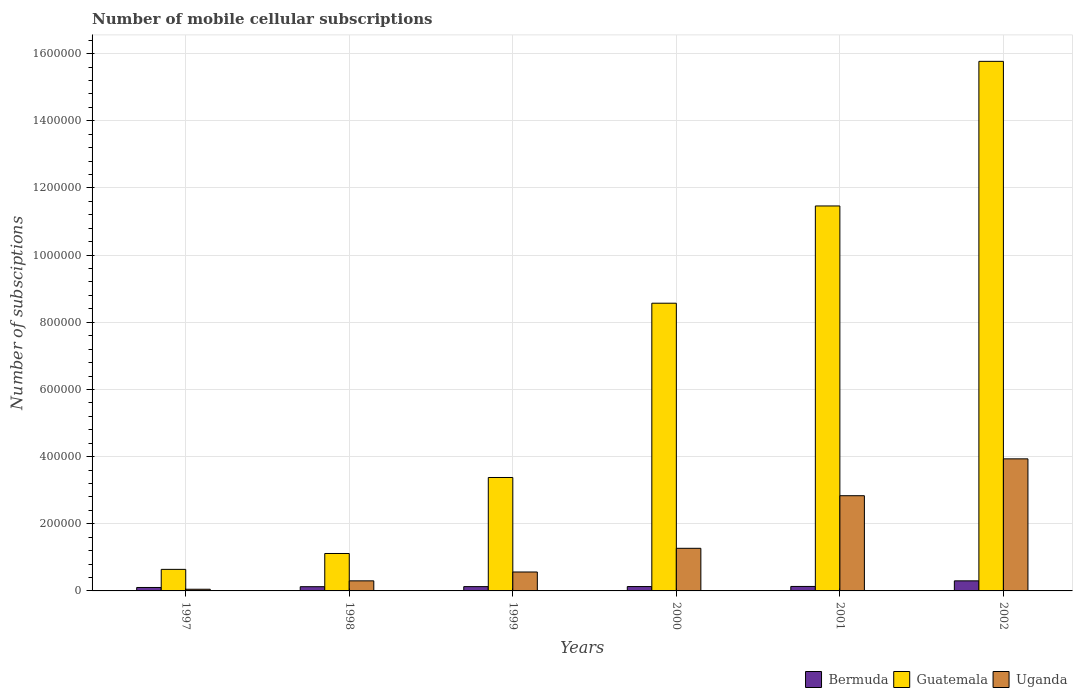How many groups of bars are there?
Make the answer very short. 6. How many bars are there on the 3rd tick from the left?
Your answer should be compact. 3. What is the label of the 6th group of bars from the left?
Give a very brief answer. 2002. What is the number of mobile cellular subscriptions in Guatemala in 2000?
Your response must be concise. 8.57e+05. Across all years, what is the minimum number of mobile cellular subscriptions in Guatemala?
Ensure brevity in your answer.  6.42e+04. In which year was the number of mobile cellular subscriptions in Guatemala maximum?
Offer a terse response. 2002. What is the total number of mobile cellular subscriptions in Guatemala in the graph?
Keep it short and to the point. 4.09e+06. What is the difference between the number of mobile cellular subscriptions in Guatemala in 1998 and that in 2000?
Make the answer very short. -7.45e+05. What is the difference between the number of mobile cellular subscriptions in Guatemala in 2002 and the number of mobile cellular subscriptions in Uganda in 1999?
Ensure brevity in your answer.  1.52e+06. What is the average number of mobile cellular subscriptions in Uganda per year?
Ensure brevity in your answer.  1.49e+05. In the year 1997, what is the difference between the number of mobile cellular subscriptions in Guatemala and number of mobile cellular subscriptions in Uganda?
Offer a terse response. 5.92e+04. What is the ratio of the number of mobile cellular subscriptions in Bermuda in 1999 to that in 2002?
Give a very brief answer. 0.43. What is the difference between the highest and the second highest number of mobile cellular subscriptions in Bermuda?
Keep it short and to the point. 1.67e+04. What is the difference between the highest and the lowest number of mobile cellular subscriptions in Guatemala?
Provide a short and direct response. 1.51e+06. In how many years, is the number of mobile cellular subscriptions in Bermuda greater than the average number of mobile cellular subscriptions in Bermuda taken over all years?
Make the answer very short. 1. Is the sum of the number of mobile cellular subscriptions in Uganda in 1998 and 1999 greater than the maximum number of mobile cellular subscriptions in Bermuda across all years?
Provide a short and direct response. Yes. What does the 1st bar from the left in 1999 represents?
Provide a succinct answer. Bermuda. What does the 2nd bar from the right in 2002 represents?
Keep it short and to the point. Guatemala. Is it the case that in every year, the sum of the number of mobile cellular subscriptions in Guatemala and number of mobile cellular subscriptions in Uganda is greater than the number of mobile cellular subscriptions in Bermuda?
Your response must be concise. Yes. What is the difference between two consecutive major ticks on the Y-axis?
Your response must be concise. 2.00e+05. Does the graph contain any zero values?
Offer a very short reply. No. Does the graph contain grids?
Provide a short and direct response. Yes. Where does the legend appear in the graph?
Your answer should be very brief. Bottom right. How many legend labels are there?
Offer a terse response. 3. How are the legend labels stacked?
Offer a terse response. Horizontal. What is the title of the graph?
Make the answer very short. Number of mobile cellular subscriptions. Does "Latin America(developing only)" appear as one of the legend labels in the graph?
Ensure brevity in your answer.  No. What is the label or title of the Y-axis?
Ensure brevity in your answer.  Number of subsciptions. What is the Number of subsciptions of Bermuda in 1997?
Offer a terse response. 1.03e+04. What is the Number of subsciptions of Guatemala in 1997?
Your response must be concise. 6.42e+04. What is the Number of subsciptions in Uganda in 1997?
Provide a short and direct response. 5000. What is the Number of subsciptions of Bermuda in 1998?
Give a very brief answer. 1.26e+04. What is the Number of subsciptions in Guatemala in 1998?
Your response must be concise. 1.11e+05. What is the Number of subsciptions in Bermuda in 1999?
Your answer should be very brief. 1.28e+04. What is the Number of subsciptions in Guatemala in 1999?
Your response must be concise. 3.38e+05. What is the Number of subsciptions in Uganda in 1999?
Provide a short and direct response. 5.64e+04. What is the Number of subsciptions in Bermuda in 2000?
Ensure brevity in your answer.  1.30e+04. What is the Number of subsciptions of Guatemala in 2000?
Give a very brief answer. 8.57e+05. What is the Number of subsciptions in Uganda in 2000?
Give a very brief answer. 1.27e+05. What is the Number of subsciptions of Bermuda in 2001?
Give a very brief answer. 1.33e+04. What is the Number of subsciptions of Guatemala in 2001?
Offer a very short reply. 1.15e+06. What is the Number of subsciptions in Uganda in 2001?
Your answer should be very brief. 2.84e+05. What is the Number of subsciptions in Bermuda in 2002?
Keep it short and to the point. 3.00e+04. What is the Number of subsciptions of Guatemala in 2002?
Keep it short and to the point. 1.58e+06. What is the Number of subsciptions of Uganda in 2002?
Your answer should be very brief. 3.93e+05. Across all years, what is the maximum Number of subsciptions of Bermuda?
Your response must be concise. 3.00e+04. Across all years, what is the maximum Number of subsciptions in Guatemala?
Offer a very short reply. 1.58e+06. Across all years, what is the maximum Number of subsciptions in Uganda?
Give a very brief answer. 3.93e+05. Across all years, what is the minimum Number of subsciptions of Bermuda?
Keep it short and to the point. 1.03e+04. Across all years, what is the minimum Number of subsciptions of Guatemala?
Provide a short and direct response. 6.42e+04. What is the total Number of subsciptions in Bermuda in the graph?
Your response must be concise. 9.20e+04. What is the total Number of subsciptions in Guatemala in the graph?
Give a very brief answer. 4.09e+06. What is the total Number of subsciptions in Uganda in the graph?
Give a very brief answer. 8.95e+05. What is the difference between the Number of subsciptions in Bermuda in 1997 and that in 1998?
Your answer should be very brief. -2296. What is the difference between the Number of subsciptions of Guatemala in 1997 and that in 1998?
Keep it short and to the point. -4.73e+04. What is the difference between the Number of subsciptions in Uganda in 1997 and that in 1998?
Your answer should be compact. -2.50e+04. What is the difference between the Number of subsciptions of Bermuda in 1997 and that in 1999?
Provide a succinct answer. -2524. What is the difference between the Number of subsciptions in Guatemala in 1997 and that in 1999?
Give a very brief answer. -2.74e+05. What is the difference between the Number of subsciptions in Uganda in 1997 and that in 1999?
Make the answer very short. -5.14e+04. What is the difference between the Number of subsciptions in Bermuda in 1997 and that in 2000?
Your answer should be compact. -2724. What is the difference between the Number of subsciptions of Guatemala in 1997 and that in 2000?
Keep it short and to the point. -7.93e+05. What is the difference between the Number of subsciptions in Uganda in 1997 and that in 2000?
Keep it short and to the point. -1.22e+05. What is the difference between the Number of subsciptions of Bermuda in 1997 and that in 2001?
Keep it short and to the point. -3057. What is the difference between the Number of subsciptions in Guatemala in 1997 and that in 2001?
Make the answer very short. -1.08e+06. What is the difference between the Number of subsciptions in Uganda in 1997 and that in 2001?
Provide a short and direct response. -2.79e+05. What is the difference between the Number of subsciptions in Bermuda in 1997 and that in 2002?
Ensure brevity in your answer.  -1.97e+04. What is the difference between the Number of subsciptions in Guatemala in 1997 and that in 2002?
Provide a short and direct response. -1.51e+06. What is the difference between the Number of subsciptions of Uganda in 1997 and that in 2002?
Keep it short and to the point. -3.88e+05. What is the difference between the Number of subsciptions of Bermuda in 1998 and that in 1999?
Your answer should be compact. -228. What is the difference between the Number of subsciptions in Guatemala in 1998 and that in 1999?
Your response must be concise. -2.26e+05. What is the difference between the Number of subsciptions of Uganda in 1998 and that in 1999?
Keep it short and to the point. -2.64e+04. What is the difference between the Number of subsciptions of Bermuda in 1998 and that in 2000?
Your answer should be very brief. -428. What is the difference between the Number of subsciptions of Guatemala in 1998 and that in 2000?
Keep it short and to the point. -7.45e+05. What is the difference between the Number of subsciptions of Uganda in 1998 and that in 2000?
Offer a very short reply. -9.69e+04. What is the difference between the Number of subsciptions of Bermuda in 1998 and that in 2001?
Offer a very short reply. -761. What is the difference between the Number of subsciptions of Guatemala in 1998 and that in 2001?
Ensure brevity in your answer.  -1.03e+06. What is the difference between the Number of subsciptions in Uganda in 1998 and that in 2001?
Offer a terse response. -2.54e+05. What is the difference between the Number of subsciptions in Bermuda in 1998 and that in 2002?
Offer a very short reply. -1.74e+04. What is the difference between the Number of subsciptions of Guatemala in 1998 and that in 2002?
Your response must be concise. -1.47e+06. What is the difference between the Number of subsciptions of Uganda in 1998 and that in 2002?
Provide a succinct answer. -3.63e+05. What is the difference between the Number of subsciptions of Bermuda in 1999 and that in 2000?
Ensure brevity in your answer.  -200. What is the difference between the Number of subsciptions of Guatemala in 1999 and that in 2000?
Your answer should be very brief. -5.19e+05. What is the difference between the Number of subsciptions in Uganda in 1999 and that in 2000?
Offer a terse response. -7.06e+04. What is the difference between the Number of subsciptions of Bermuda in 1999 and that in 2001?
Give a very brief answer. -533. What is the difference between the Number of subsciptions of Guatemala in 1999 and that in 2001?
Provide a short and direct response. -8.09e+05. What is the difference between the Number of subsciptions in Uganda in 1999 and that in 2001?
Offer a very short reply. -2.27e+05. What is the difference between the Number of subsciptions of Bermuda in 1999 and that in 2002?
Provide a short and direct response. -1.72e+04. What is the difference between the Number of subsciptions in Guatemala in 1999 and that in 2002?
Offer a very short reply. -1.24e+06. What is the difference between the Number of subsciptions in Uganda in 1999 and that in 2002?
Offer a very short reply. -3.37e+05. What is the difference between the Number of subsciptions of Bermuda in 2000 and that in 2001?
Provide a short and direct response. -333. What is the difference between the Number of subsciptions of Guatemala in 2000 and that in 2001?
Ensure brevity in your answer.  -2.90e+05. What is the difference between the Number of subsciptions in Uganda in 2000 and that in 2001?
Give a very brief answer. -1.57e+05. What is the difference between the Number of subsciptions in Bermuda in 2000 and that in 2002?
Make the answer very short. -1.70e+04. What is the difference between the Number of subsciptions of Guatemala in 2000 and that in 2002?
Offer a very short reply. -7.20e+05. What is the difference between the Number of subsciptions in Uganda in 2000 and that in 2002?
Your response must be concise. -2.66e+05. What is the difference between the Number of subsciptions of Bermuda in 2001 and that in 2002?
Make the answer very short. -1.67e+04. What is the difference between the Number of subsciptions in Guatemala in 2001 and that in 2002?
Your answer should be compact. -4.31e+05. What is the difference between the Number of subsciptions in Uganda in 2001 and that in 2002?
Ensure brevity in your answer.  -1.10e+05. What is the difference between the Number of subsciptions in Bermuda in 1997 and the Number of subsciptions in Guatemala in 1998?
Your answer should be compact. -1.01e+05. What is the difference between the Number of subsciptions of Bermuda in 1997 and the Number of subsciptions of Uganda in 1998?
Your response must be concise. -1.97e+04. What is the difference between the Number of subsciptions of Guatemala in 1997 and the Number of subsciptions of Uganda in 1998?
Provide a short and direct response. 3.42e+04. What is the difference between the Number of subsciptions of Bermuda in 1997 and the Number of subsciptions of Guatemala in 1999?
Keep it short and to the point. -3.28e+05. What is the difference between the Number of subsciptions of Bermuda in 1997 and the Number of subsciptions of Uganda in 1999?
Your answer should be very brief. -4.61e+04. What is the difference between the Number of subsciptions of Guatemala in 1997 and the Number of subsciptions of Uganda in 1999?
Your answer should be compact. 7836. What is the difference between the Number of subsciptions in Bermuda in 1997 and the Number of subsciptions in Guatemala in 2000?
Your answer should be very brief. -8.47e+05. What is the difference between the Number of subsciptions in Bermuda in 1997 and the Number of subsciptions in Uganda in 2000?
Make the answer very short. -1.17e+05. What is the difference between the Number of subsciptions in Guatemala in 1997 and the Number of subsciptions in Uganda in 2000?
Make the answer very short. -6.27e+04. What is the difference between the Number of subsciptions in Bermuda in 1997 and the Number of subsciptions in Guatemala in 2001?
Your response must be concise. -1.14e+06. What is the difference between the Number of subsciptions in Bermuda in 1997 and the Number of subsciptions in Uganda in 2001?
Offer a very short reply. -2.73e+05. What is the difference between the Number of subsciptions in Guatemala in 1997 and the Number of subsciptions in Uganda in 2001?
Make the answer very short. -2.19e+05. What is the difference between the Number of subsciptions of Bermuda in 1997 and the Number of subsciptions of Guatemala in 2002?
Your answer should be very brief. -1.57e+06. What is the difference between the Number of subsciptions in Bermuda in 1997 and the Number of subsciptions in Uganda in 2002?
Make the answer very short. -3.83e+05. What is the difference between the Number of subsciptions in Guatemala in 1997 and the Number of subsciptions in Uganda in 2002?
Your response must be concise. -3.29e+05. What is the difference between the Number of subsciptions of Bermuda in 1998 and the Number of subsciptions of Guatemala in 1999?
Provide a short and direct response. -3.25e+05. What is the difference between the Number of subsciptions in Bermuda in 1998 and the Number of subsciptions in Uganda in 1999?
Offer a very short reply. -4.38e+04. What is the difference between the Number of subsciptions of Guatemala in 1998 and the Number of subsciptions of Uganda in 1999?
Provide a succinct answer. 5.51e+04. What is the difference between the Number of subsciptions of Bermuda in 1998 and the Number of subsciptions of Guatemala in 2000?
Keep it short and to the point. -8.44e+05. What is the difference between the Number of subsciptions in Bermuda in 1998 and the Number of subsciptions in Uganda in 2000?
Offer a very short reply. -1.14e+05. What is the difference between the Number of subsciptions in Guatemala in 1998 and the Number of subsciptions in Uganda in 2000?
Your answer should be very brief. -1.55e+04. What is the difference between the Number of subsciptions of Bermuda in 1998 and the Number of subsciptions of Guatemala in 2001?
Provide a short and direct response. -1.13e+06. What is the difference between the Number of subsciptions of Bermuda in 1998 and the Number of subsciptions of Uganda in 2001?
Give a very brief answer. -2.71e+05. What is the difference between the Number of subsciptions in Guatemala in 1998 and the Number of subsciptions in Uganda in 2001?
Your answer should be compact. -1.72e+05. What is the difference between the Number of subsciptions in Bermuda in 1998 and the Number of subsciptions in Guatemala in 2002?
Offer a terse response. -1.56e+06. What is the difference between the Number of subsciptions of Bermuda in 1998 and the Number of subsciptions of Uganda in 2002?
Offer a very short reply. -3.81e+05. What is the difference between the Number of subsciptions in Guatemala in 1998 and the Number of subsciptions in Uganda in 2002?
Offer a very short reply. -2.82e+05. What is the difference between the Number of subsciptions of Bermuda in 1999 and the Number of subsciptions of Guatemala in 2000?
Your answer should be compact. -8.44e+05. What is the difference between the Number of subsciptions of Bermuda in 1999 and the Number of subsciptions of Uganda in 2000?
Provide a succinct answer. -1.14e+05. What is the difference between the Number of subsciptions in Guatemala in 1999 and the Number of subsciptions in Uganda in 2000?
Provide a short and direct response. 2.11e+05. What is the difference between the Number of subsciptions of Bermuda in 1999 and the Number of subsciptions of Guatemala in 2001?
Give a very brief answer. -1.13e+06. What is the difference between the Number of subsciptions in Bermuda in 1999 and the Number of subsciptions in Uganda in 2001?
Provide a succinct answer. -2.71e+05. What is the difference between the Number of subsciptions in Guatemala in 1999 and the Number of subsciptions in Uganda in 2001?
Your response must be concise. 5.43e+04. What is the difference between the Number of subsciptions in Bermuda in 1999 and the Number of subsciptions in Guatemala in 2002?
Offer a terse response. -1.56e+06. What is the difference between the Number of subsciptions of Bermuda in 1999 and the Number of subsciptions of Uganda in 2002?
Your response must be concise. -3.81e+05. What is the difference between the Number of subsciptions in Guatemala in 1999 and the Number of subsciptions in Uganda in 2002?
Give a very brief answer. -5.55e+04. What is the difference between the Number of subsciptions of Bermuda in 2000 and the Number of subsciptions of Guatemala in 2001?
Your response must be concise. -1.13e+06. What is the difference between the Number of subsciptions of Bermuda in 2000 and the Number of subsciptions of Uganda in 2001?
Your answer should be compact. -2.71e+05. What is the difference between the Number of subsciptions in Guatemala in 2000 and the Number of subsciptions in Uganda in 2001?
Provide a short and direct response. 5.73e+05. What is the difference between the Number of subsciptions of Bermuda in 2000 and the Number of subsciptions of Guatemala in 2002?
Keep it short and to the point. -1.56e+06. What is the difference between the Number of subsciptions of Bermuda in 2000 and the Number of subsciptions of Uganda in 2002?
Keep it short and to the point. -3.80e+05. What is the difference between the Number of subsciptions in Guatemala in 2000 and the Number of subsciptions in Uganda in 2002?
Provide a short and direct response. 4.64e+05. What is the difference between the Number of subsciptions in Bermuda in 2001 and the Number of subsciptions in Guatemala in 2002?
Ensure brevity in your answer.  -1.56e+06. What is the difference between the Number of subsciptions of Bermuda in 2001 and the Number of subsciptions of Uganda in 2002?
Provide a short and direct response. -3.80e+05. What is the difference between the Number of subsciptions in Guatemala in 2001 and the Number of subsciptions in Uganda in 2002?
Make the answer very short. 7.53e+05. What is the average Number of subsciptions in Bermuda per year?
Offer a very short reply. 1.53e+04. What is the average Number of subsciptions of Guatemala per year?
Provide a short and direct response. 6.82e+05. What is the average Number of subsciptions in Uganda per year?
Offer a very short reply. 1.49e+05. In the year 1997, what is the difference between the Number of subsciptions in Bermuda and Number of subsciptions in Guatemala?
Ensure brevity in your answer.  -5.39e+04. In the year 1997, what is the difference between the Number of subsciptions in Bermuda and Number of subsciptions in Uganda?
Give a very brief answer. 5276. In the year 1997, what is the difference between the Number of subsciptions of Guatemala and Number of subsciptions of Uganda?
Ensure brevity in your answer.  5.92e+04. In the year 1998, what is the difference between the Number of subsciptions in Bermuda and Number of subsciptions in Guatemala?
Provide a succinct answer. -9.89e+04. In the year 1998, what is the difference between the Number of subsciptions in Bermuda and Number of subsciptions in Uganda?
Offer a very short reply. -1.74e+04. In the year 1998, what is the difference between the Number of subsciptions in Guatemala and Number of subsciptions in Uganda?
Offer a terse response. 8.14e+04. In the year 1999, what is the difference between the Number of subsciptions of Bermuda and Number of subsciptions of Guatemala?
Offer a terse response. -3.25e+05. In the year 1999, what is the difference between the Number of subsciptions of Bermuda and Number of subsciptions of Uganda?
Offer a very short reply. -4.36e+04. In the year 1999, what is the difference between the Number of subsciptions of Guatemala and Number of subsciptions of Uganda?
Offer a terse response. 2.81e+05. In the year 2000, what is the difference between the Number of subsciptions of Bermuda and Number of subsciptions of Guatemala?
Your answer should be very brief. -8.44e+05. In the year 2000, what is the difference between the Number of subsciptions of Bermuda and Number of subsciptions of Uganda?
Provide a succinct answer. -1.14e+05. In the year 2000, what is the difference between the Number of subsciptions of Guatemala and Number of subsciptions of Uganda?
Your answer should be compact. 7.30e+05. In the year 2001, what is the difference between the Number of subsciptions in Bermuda and Number of subsciptions in Guatemala?
Your answer should be very brief. -1.13e+06. In the year 2001, what is the difference between the Number of subsciptions in Bermuda and Number of subsciptions in Uganda?
Make the answer very short. -2.70e+05. In the year 2001, what is the difference between the Number of subsciptions of Guatemala and Number of subsciptions of Uganda?
Give a very brief answer. 8.63e+05. In the year 2002, what is the difference between the Number of subsciptions of Bermuda and Number of subsciptions of Guatemala?
Your response must be concise. -1.55e+06. In the year 2002, what is the difference between the Number of subsciptions of Bermuda and Number of subsciptions of Uganda?
Offer a very short reply. -3.63e+05. In the year 2002, what is the difference between the Number of subsciptions in Guatemala and Number of subsciptions in Uganda?
Your answer should be very brief. 1.18e+06. What is the ratio of the Number of subsciptions in Bermuda in 1997 to that in 1998?
Give a very brief answer. 0.82. What is the ratio of the Number of subsciptions in Guatemala in 1997 to that in 1998?
Make the answer very short. 0.58. What is the ratio of the Number of subsciptions in Bermuda in 1997 to that in 1999?
Your answer should be very brief. 0.8. What is the ratio of the Number of subsciptions in Guatemala in 1997 to that in 1999?
Give a very brief answer. 0.19. What is the ratio of the Number of subsciptions of Uganda in 1997 to that in 1999?
Provide a succinct answer. 0.09. What is the ratio of the Number of subsciptions in Bermuda in 1997 to that in 2000?
Keep it short and to the point. 0.79. What is the ratio of the Number of subsciptions in Guatemala in 1997 to that in 2000?
Your answer should be very brief. 0.07. What is the ratio of the Number of subsciptions of Uganda in 1997 to that in 2000?
Provide a succinct answer. 0.04. What is the ratio of the Number of subsciptions of Bermuda in 1997 to that in 2001?
Offer a terse response. 0.77. What is the ratio of the Number of subsciptions of Guatemala in 1997 to that in 2001?
Your answer should be very brief. 0.06. What is the ratio of the Number of subsciptions in Uganda in 1997 to that in 2001?
Give a very brief answer. 0.02. What is the ratio of the Number of subsciptions of Bermuda in 1997 to that in 2002?
Provide a succinct answer. 0.34. What is the ratio of the Number of subsciptions of Guatemala in 1997 to that in 2002?
Your answer should be very brief. 0.04. What is the ratio of the Number of subsciptions of Uganda in 1997 to that in 2002?
Offer a very short reply. 0.01. What is the ratio of the Number of subsciptions of Bermuda in 1998 to that in 1999?
Your answer should be very brief. 0.98. What is the ratio of the Number of subsciptions of Guatemala in 1998 to that in 1999?
Offer a terse response. 0.33. What is the ratio of the Number of subsciptions of Uganda in 1998 to that in 1999?
Your response must be concise. 0.53. What is the ratio of the Number of subsciptions in Bermuda in 1998 to that in 2000?
Ensure brevity in your answer.  0.97. What is the ratio of the Number of subsciptions of Guatemala in 1998 to that in 2000?
Keep it short and to the point. 0.13. What is the ratio of the Number of subsciptions in Uganda in 1998 to that in 2000?
Keep it short and to the point. 0.24. What is the ratio of the Number of subsciptions of Bermuda in 1998 to that in 2001?
Provide a succinct answer. 0.94. What is the ratio of the Number of subsciptions of Guatemala in 1998 to that in 2001?
Ensure brevity in your answer.  0.1. What is the ratio of the Number of subsciptions of Uganda in 1998 to that in 2001?
Make the answer very short. 0.11. What is the ratio of the Number of subsciptions of Bermuda in 1998 to that in 2002?
Offer a very short reply. 0.42. What is the ratio of the Number of subsciptions in Guatemala in 1998 to that in 2002?
Provide a short and direct response. 0.07. What is the ratio of the Number of subsciptions of Uganda in 1998 to that in 2002?
Offer a very short reply. 0.08. What is the ratio of the Number of subsciptions of Bermuda in 1999 to that in 2000?
Make the answer very short. 0.98. What is the ratio of the Number of subsciptions of Guatemala in 1999 to that in 2000?
Give a very brief answer. 0.39. What is the ratio of the Number of subsciptions in Uganda in 1999 to that in 2000?
Provide a short and direct response. 0.44. What is the ratio of the Number of subsciptions of Bermuda in 1999 to that in 2001?
Make the answer very short. 0.96. What is the ratio of the Number of subsciptions of Guatemala in 1999 to that in 2001?
Provide a short and direct response. 0.29. What is the ratio of the Number of subsciptions of Uganda in 1999 to that in 2001?
Your response must be concise. 0.2. What is the ratio of the Number of subsciptions of Bermuda in 1999 to that in 2002?
Your answer should be compact. 0.43. What is the ratio of the Number of subsciptions in Guatemala in 1999 to that in 2002?
Ensure brevity in your answer.  0.21. What is the ratio of the Number of subsciptions in Uganda in 1999 to that in 2002?
Keep it short and to the point. 0.14. What is the ratio of the Number of subsciptions in Bermuda in 2000 to that in 2001?
Provide a short and direct response. 0.97. What is the ratio of the Number of subsciptions of Guatemala in 2000 to that in 2001?
Ensure brevity in your answer.  0.75. What is the ratio of the Number of subsciptions of Uganda in 2000 to that in 2001?
Your response must be concise. 0.45. What is the ratio of the Number of subsciptions in Bermuda in 2000 to that in 2002?
Make the answer very short. 0.43. What is the ratio of the Number of subsciptions of Guatemala in 2000 to that in 2002?
Ensure brevity in your answer.  0.54. What is the ratio of the Number of subsciptions in Uganda in 2000 to that in 2002?
Make the answer very short. 0.32. What is the ratio of the Number of subsciptions in Bermuda in 2001 to that in 2002?
Make the answer very short. 0.44. What is the ratio of the Number of subsciptions in Guatemala in 2001 to that in 2002?
Your answer should be compact. 0.73. What is the ratio of the Number of subsciptions of Uganda in 2001 to that in 2002?
Offer a terse response. 0.72. What is the difference between the highest and the second highest Number of subsciptions of Bermuda?
Offer a very short reply. 1.67e+04. What is the difference between the highest and the second highest Number of subsciptions in Guatemala?
Your response must be concise. 4.31e+05. What is the difference between the highest and the second highest Number of subsciptions of Uganda?
Keep it short and to the point. 1.10e+05. What is the difference between the highest and the lowest Number of subsciptions of Bermuda?
Your answer should be compact. 1.97e+04. What is the difference between the highest and the lowest Number of subsciptions of Guatemala?
Offer a very short reply. 1.51e+06. What is the difference between the highest and the lowest Number of subsciptions of Uganda?
Offer a terse response. 3.88e+05. 